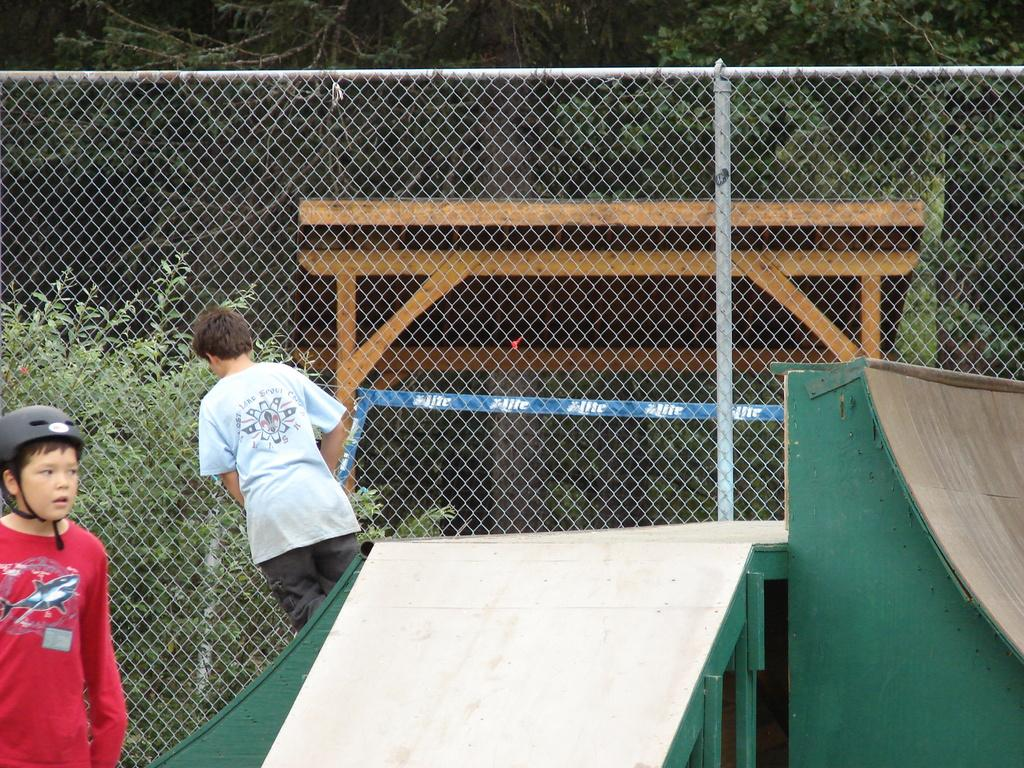Where was the image taken? The image was taken in a skate park. What can be seen on the left side of the image? There are two kids on the left side of the image. What is located in the center of the image? There is a fencing in the center of the image. What is visible outside the fencing? Trees and wooden frames are present outside the fencing. Can you tell me what type of grape the father is holding in the image? There is no father or grape present in the image. Is the frog jumping over the fencing in the image? There is no frog present in the image. 